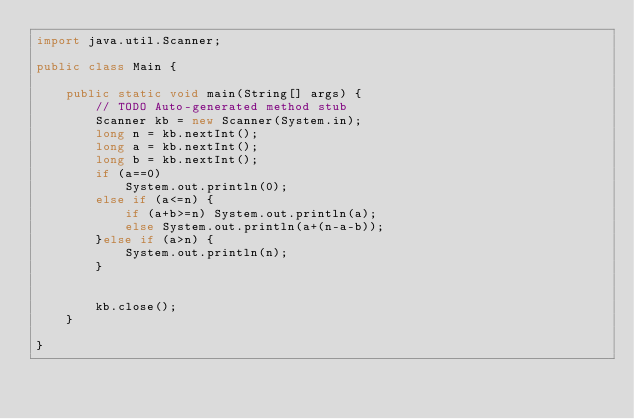<code> <loc_0><loc_0><loc_500><loc_500><_Java_>import java.util.Scanner;

public class Main {

	public static void main(String[] args) {
		// TODO Auto-generated method stub
		Scanner kb = new Scanner(System.in);
		long n = kb.nextInt();
		long a = kb.nextInt();
		long b = kb.nextInt();
		if (a==0) 
			System.out.println(0);
		else if (a<=n) {
			if (a+b>=n) System.out.println(a);
			else System.out.println(a+(n-a-b));
		}else if (a>n) {
			System.out.println(n);
		}
		
		
		kb.close();
	}

}
</code> 